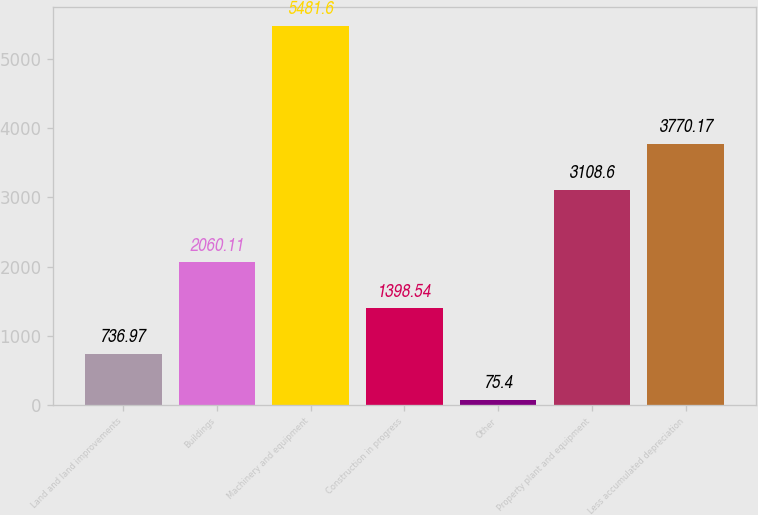<chart> <loc_0><loc_0><loc_500><loc_500><bar_chart><fcel>Land and land improvements<fcel>Buildings<fcel>Machinery and equipment<fcel>Construction in progress<fcel>Other<fcel>Property plant and equipment<fcel>Less accumulated depreciation<nl><fcel>736.97<fcel>2060.11<fcel>5481.6<fcel>1398.54<fcel>75.4<fcel>3108.6<fcel>3770.17<nl></chart> 